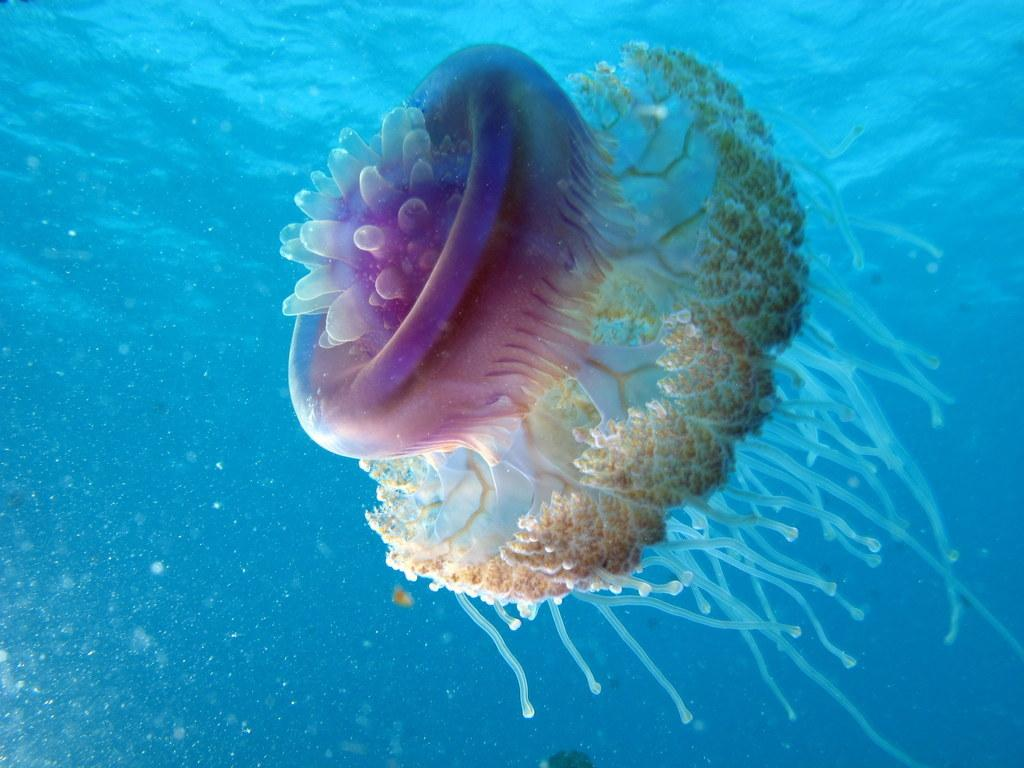What type of animal is in the image? There is a jellyfish in the image. Where is the jellyfish located? The jellyfish is in the water. How many cows are present on the seashore in the image? There are no cows or seashore present in the image; it features a jellyfish in the water. What type of mask is the jellyfish wearing in the image? Jellyfish do not wear masks, and there is no mask present in the image. 